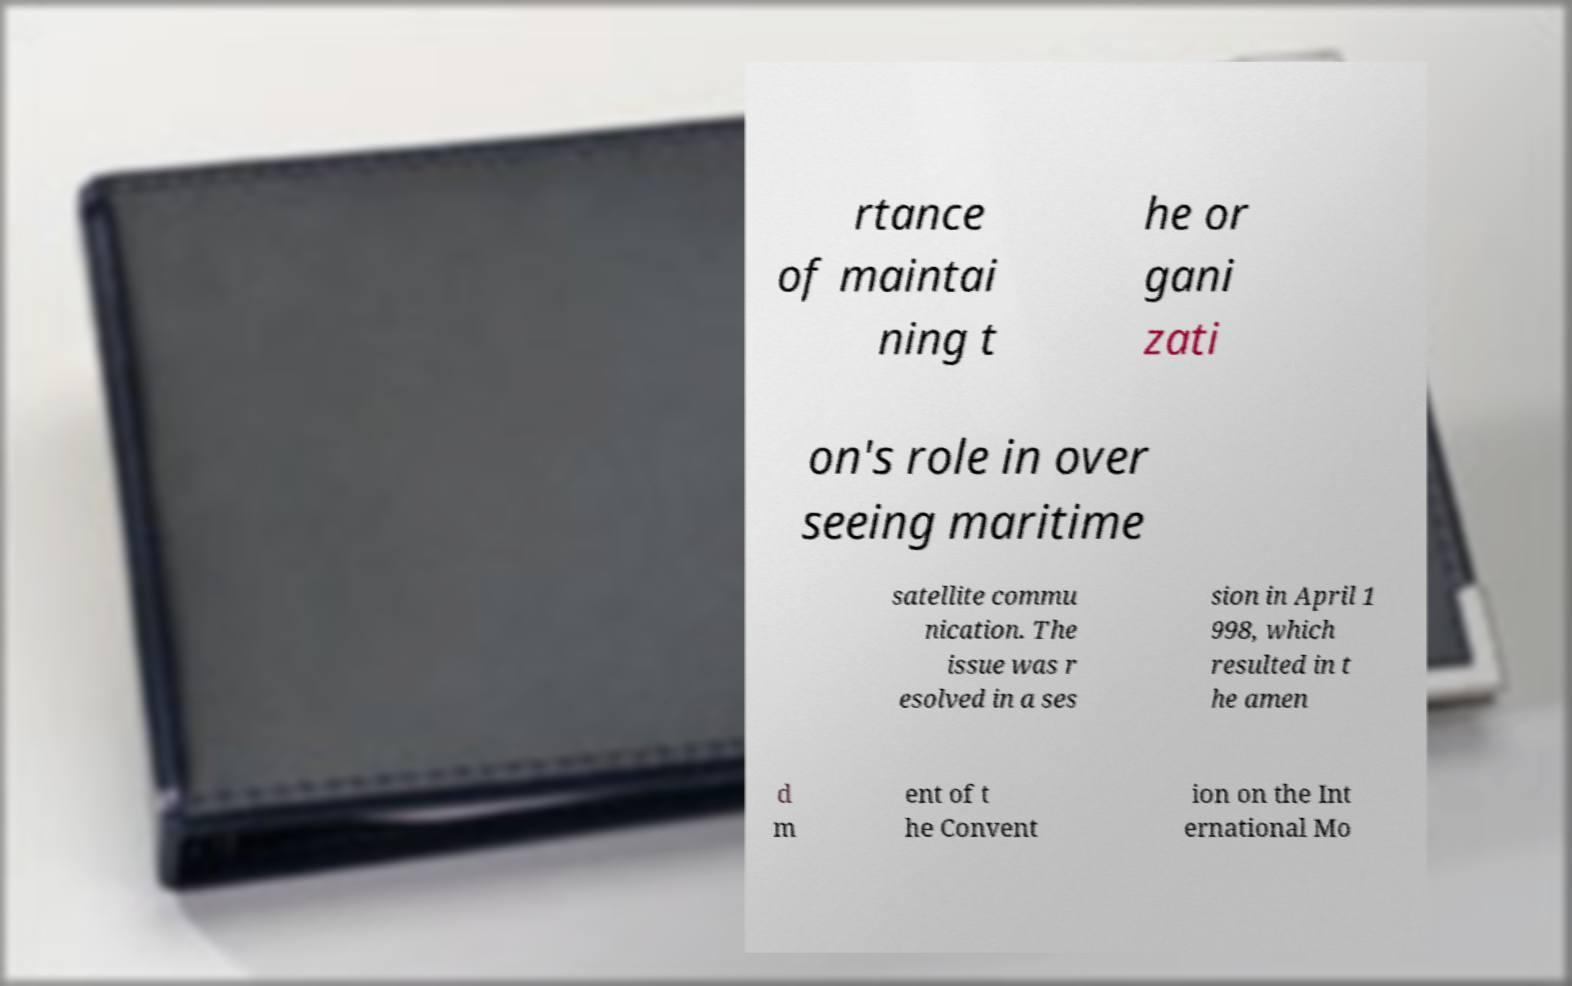Could you extract and type out the text from this image? rtance of maintai ning t he or gani zati on's role in over seeing maritime satellite commu nication. The issue was r esolved in a ses sion in April 1 998, which resulted in t he amen d m ent of t he Convent ion on the Int ernational Mo 